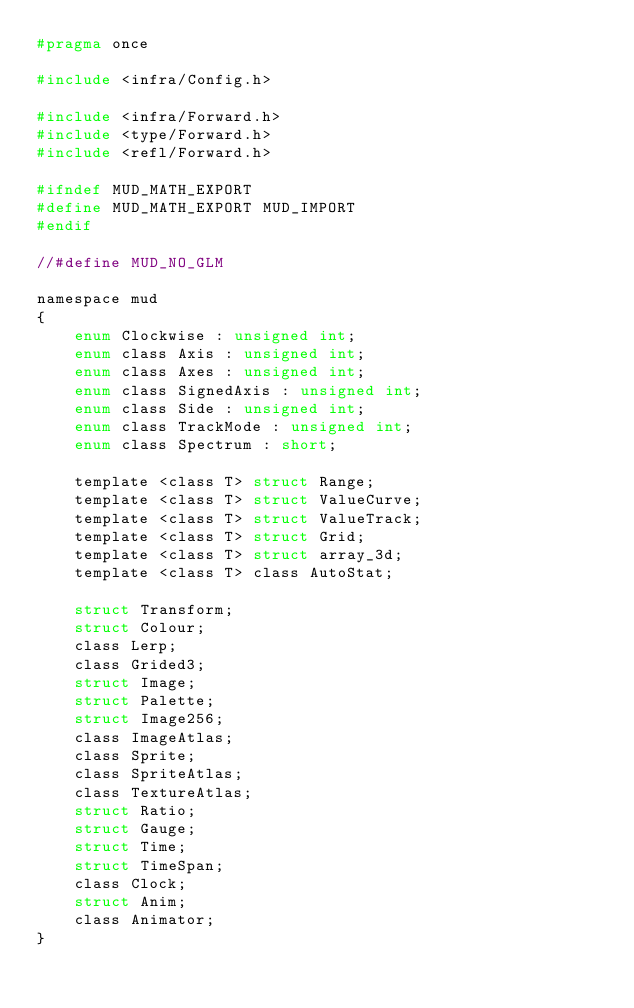Convert code to text. <code><loc_0><loc_0><loc_500><loc_500><_C_>#pragma once

#include <infra/Config.h>

#include <infra/Forward.h>
#include <type/Forward.h>
#include <refl/Forward.h>

#ifndef MUD_MATH_EXPORT
#define MUD_MATH_EXPORT MUD_IMPORT
#endif

//#define MUD_NO_GLM

namespace mud
{
    enum Clockwise : unsigned int;
    enum class Axis : unsigned int;
    enum class Axes : unsigned int;
    enum class SignedAxis : unsigned int;
    enum class Side : unsigned int;
    enum class TrackMode : unsigned int;
    enum class Spectrum : short;
    
    template <class T> struct Range;
    template <class T> struct ValueCurve;
    template <class T> struct ValueTrack;
    template <class T> struct Grid;
    template <class T> struct array_3d;
    template <class T> class AutoStat;
    
    struct Transform;
    struct Colour;
    class Lerp;
    class Grided3;
    struct Image;
    struct Palette;
    struct Image256;
    class ImageAtlas;
    class Sprite;
    class SpriteAtlas;
	class TextureAtlas;
    struct Ratio;
    struct Gauge;
    struct Time;
    struct TimeSpan;
    class Clock;
    struct Anim;
    class Animator;
}
</code> 